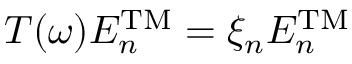Convert formula to latex. <formula><loc_0><loc_0><loc_500><loc_500>T ( \omega ) E _ { n } ^ { T M } = \xi _ { n } E _ { n } ^ { T M }</formula> 